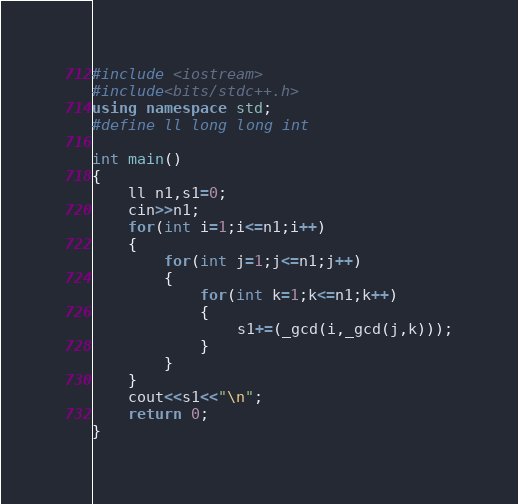Convert code to text. <code><loc_0><loc_0><loc_500><loc_500><_C++_>#include <iostream>
#include<bits/stdc++.h>
using namespace std;
#define ll long long int

int main() 
{
	ll n1,s1=0;
	cin>>n1;
	for(int i=1;i<=n1;i++)
	{
	    for(int j=1;j<=n1;j++)
	    {
	        for(int k=1;k<=n1;k++)
	        {
	            s1+=(_gcd(i,_gcd(j,k)));
	        }
	    }
	}
	cout<<s1<<"\n";
	return 0;
}</code> 